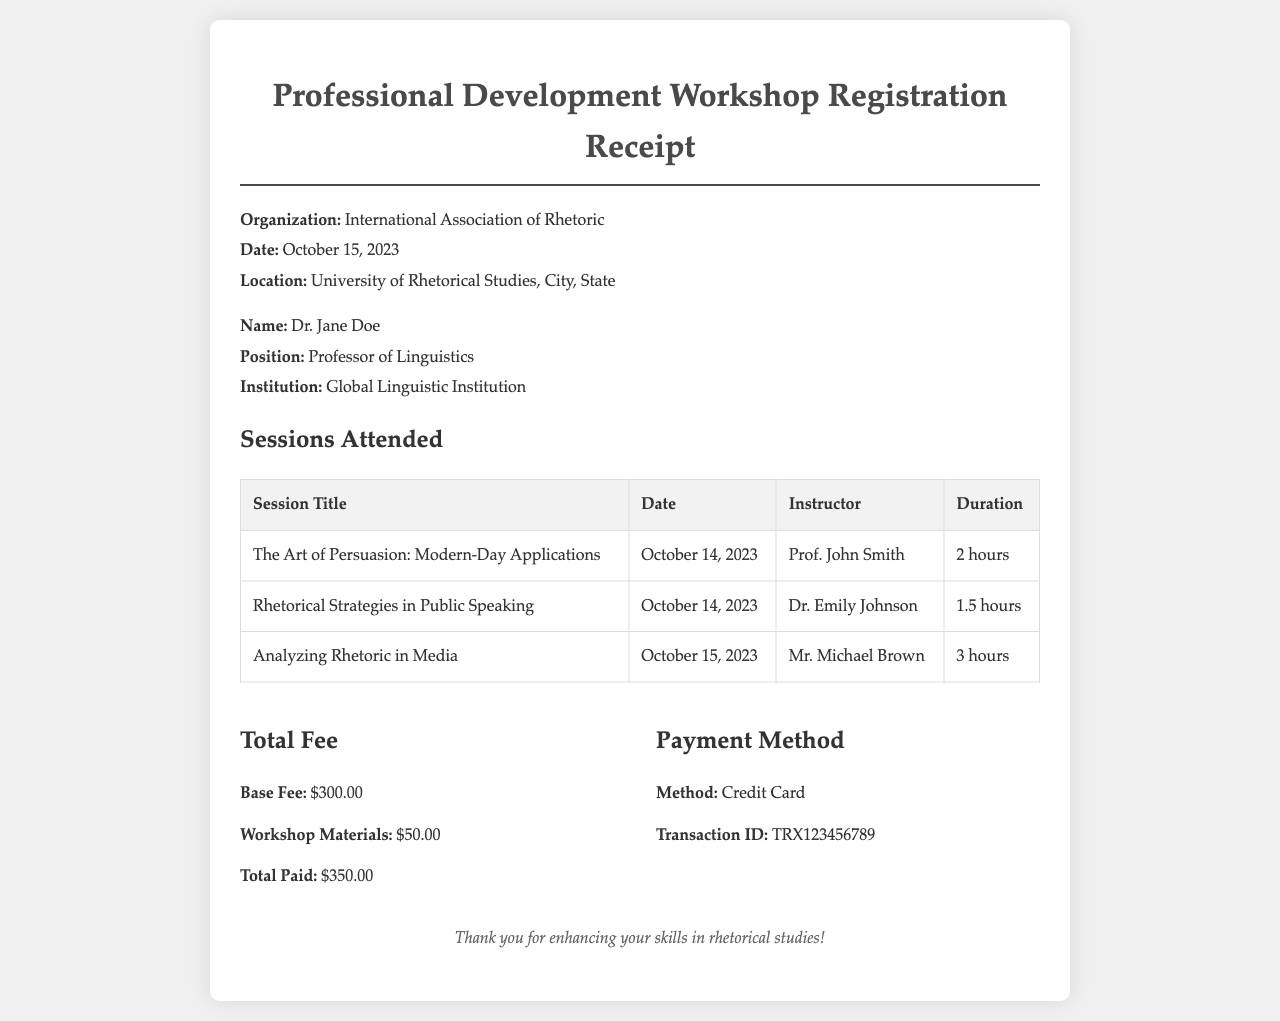What is the name of the attendee? The document lists the attendee's name as Dr. Jane Doe.
Answer: Dr. Jane Doe What sessions did Dr. Jane Doe attend? The document provides a table of sessions attended, which includes titles like "The Art of Persuasion: Modern-Day Applications," "Rhetorical Strategies in Public Speaking," and "Analyzing Rhetoric in Media."
Answer: The Art of Persuasion: Modern-Day Applications, Rhetorical Strategies in Public Speaking, Analyzing Rhetoric in Media What was the total fee paid? The total fee paid is explicitly stated in the payment section of the document.
Answer: $350.00 Who was the instructor for "Analyzing Rhetoric in Media"? The instructor's name is mentioned in the sessions table for the respective session title.
Answer: Mr. Michael Brown What date was the workshop held? The date of the workshop and sessions is provided in the header of the document.
Answer: October 14, 2023 What payment method was used? The payment method is detailed in the payment information section of the receipt.
Answer: Credit Card How long was the session "Rhetorical Strategies in Public Speaking"? The duration of the session is listed in the sessions table.
Answer: 1.5 hours What is the transaction ID for the payment? The transaction ID is provided in the payment method section of the document.
Answer: TRX123456789 